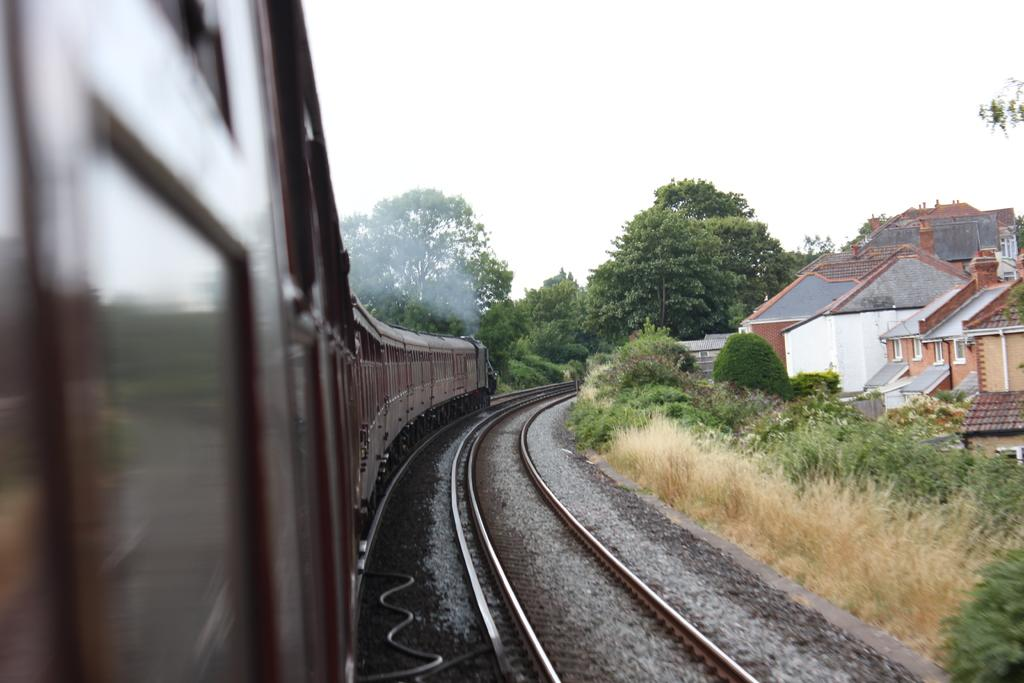What is the main subject of the image? The main subject of the image is a train on the railway track. What can be seen on the right side of the image? There are plants and buildings on the right side of the image. What is visible in the background of the image? There are trees and the sky visible in the background of the image. What is the tendency of the money in the image? There is no money present in the image, so it is not possible to determine any tendency. 